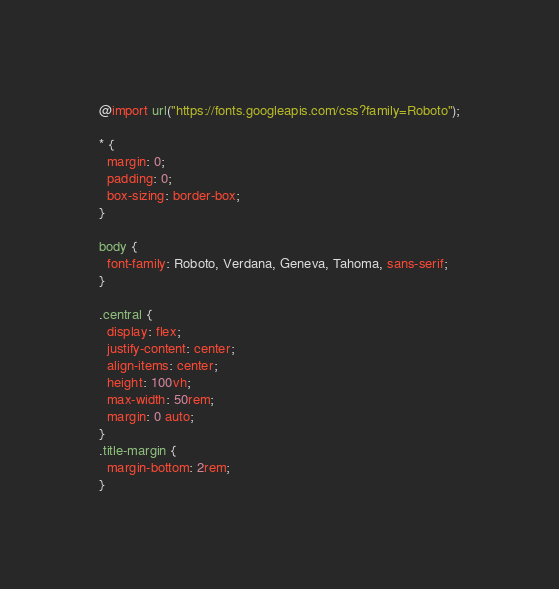<code> <loc_0><loc_0><loc_500><loc_500><_CSS_>@import url("https://fonts.googleapis.com/css?family=Roboto");

* {
  margin: 0;
  padding: 0;
  box-sizing: border-box;
}

body {
  font-family: Roboto, Verdana, Geneva, Tahoma, sans-serif;
}

.central {
  display: flex;
  justify-content: center;
  align-items: center;
  height: 100vh;
  max-width: 50rem;
  margin: 0 auto;
}
.title-margin {
  margin-bottom: 2rem;
}
</code> 